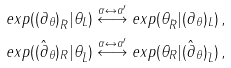<formula> <loc_0><loc_0><loc_500><loc_500>e x p ( ( \partial _ { \theta } ) _ { \bar { R } } | \theta _ { L } ) & \overset { \alpha \leftrightarrow \alpha ^ { \prime } } { \longleftrightarrow } e x p ( \theta _ { \bar { R } } | ( \partial _ { \theta } ) _ { L } ) \, , \\ e x p ( ( \hat { \partial } _ { \theta } ) _ { R } | \theta _ { \bar { L } } ) & \overset { \alpha \leftrightarrow \alpha ^ { \prime } } { \longleftrightarrow } e x p ( \theta _ { R } | ( \hat { \partial } _ { \theta } ) _ { \bar { L } } ) \, ,</formula> 